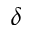Convert formula to latex. <formula><loc_0><loc_0><loc_500><loc_500>\delta</formula> 